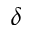Convert formula to latex. <formula><loc_0><loc_0><loc_500><loc_500>\delta</formula> 